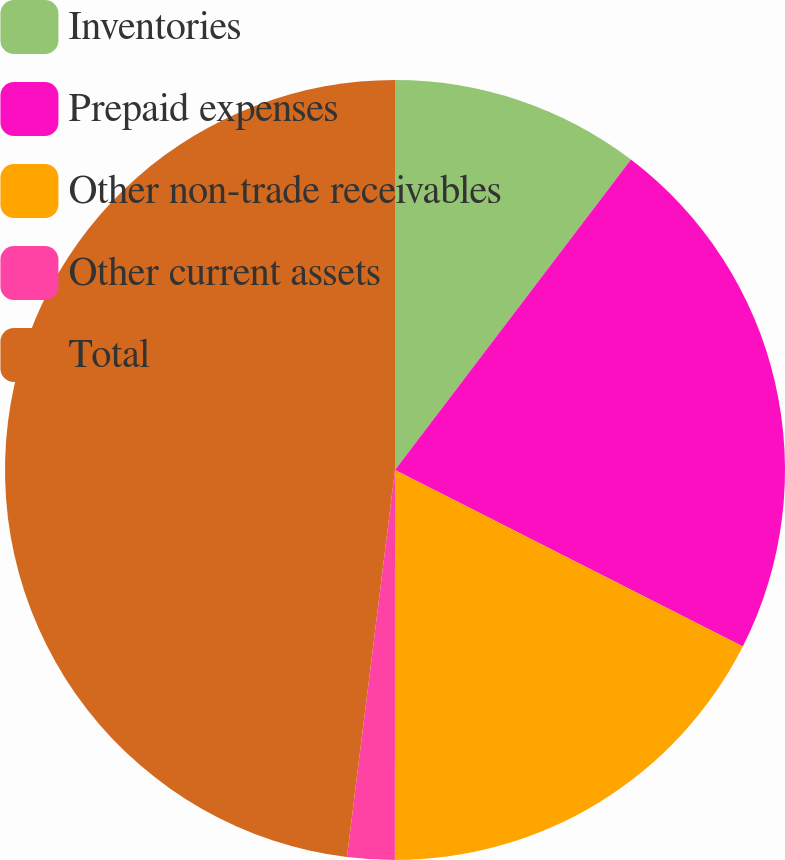Convert chart. <chart><loc_0><loc_0><loc_500><loc_500><pie_chart><fcel>Inventories<fcel>Prepaid expenses<fcel>Other non-trade receivables<fcel>Other current assets<fcel>Total<nl><fcel>10.34%<fcel>22.13%<fcel>17.53%<fcel>1.96%<fcel>48.03%<nl></chart> 